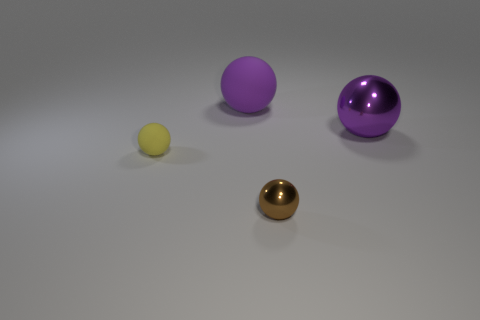Subtract all tiny metal balls. How many balls are left? 3 Subtract all blue cubes. How many brown balls are left? 1 Subtract all yellow spheres. How many spheres are left? 3 Add 4 yellow things. How many yellow things are left? 5 Add 4 metallic things. How many metallic things exist? 6 Add 2 big yellow rubber spheres. How many objects exist? 6 Subtract 0 red balls. How many objects are left? 4 Subtract 1 spheres. How many spheres are left? 3 Subtract all red spheres. Subtract all purple blocks. How many spheres are left? 4 Subtract all big matte objects. Subtract all big objects. How many objects are left? 1 